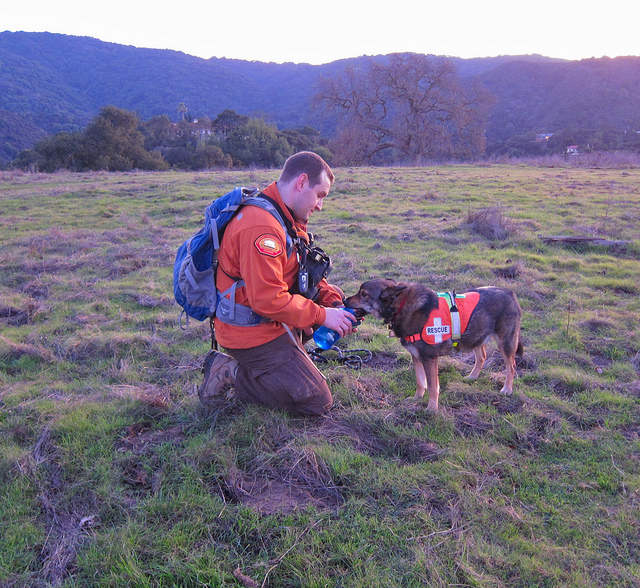Read all the text in this image. RESCUE 